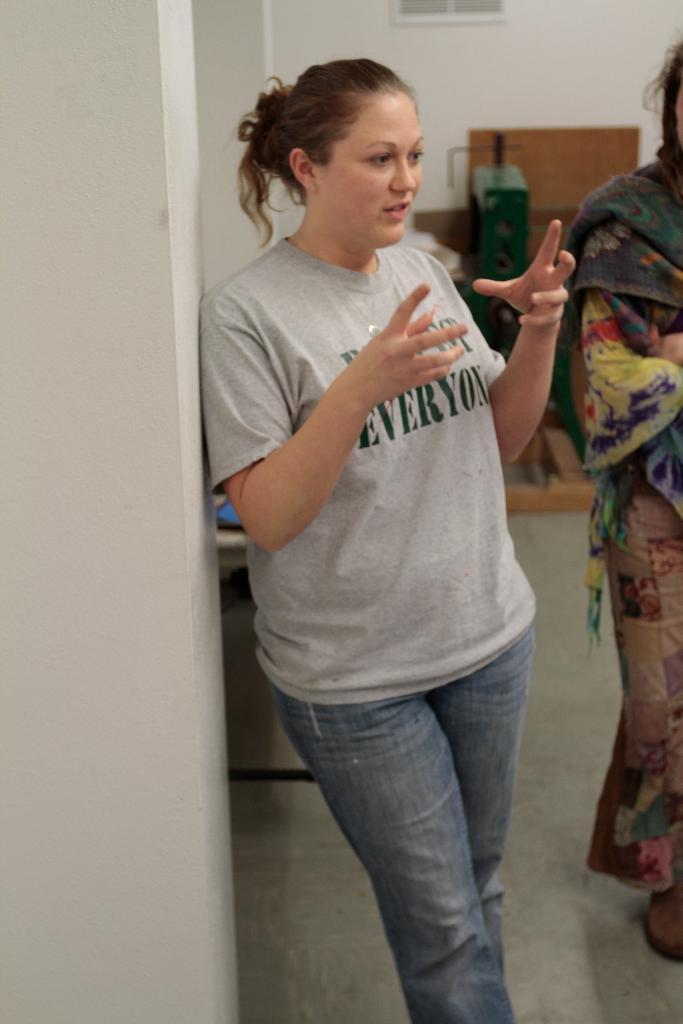How would you summarize this image in a sentence or two? In this image in the center there is one woman who is standing and talking, and beside her there is another person. And in the background there are objects and wall and on the left side of the image there is wall, at the bottom there is floor. 